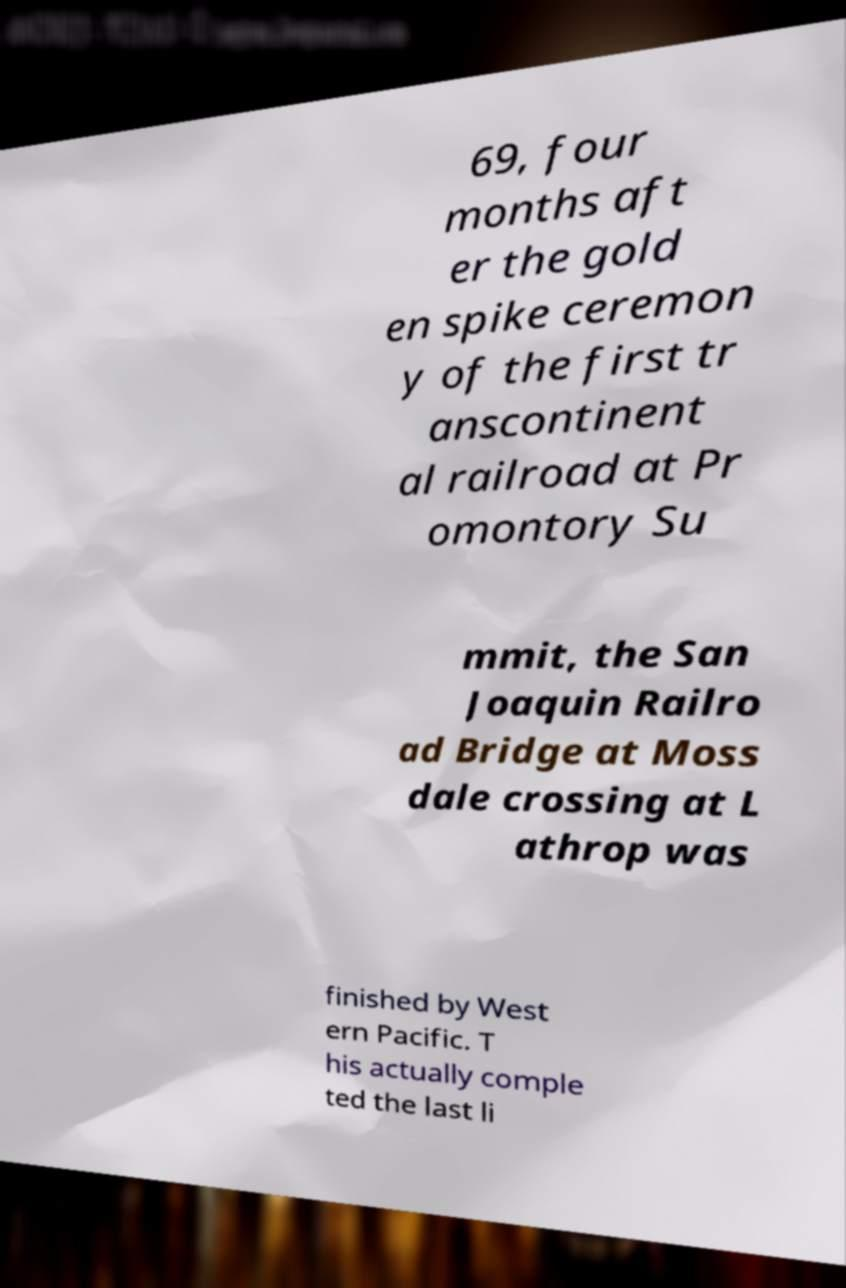Could you assist in decoding the text presented in this image and type it out clearly? 69, four months aft er the gold en spike ceremon y of the first tr anscontinent al railroad at Pr omontory Su mmit, the San Joaquin Railro ad Bridge at Moss dale crossing at L athrop was finished by West ern Pacific. T his actually comple ted the last li 